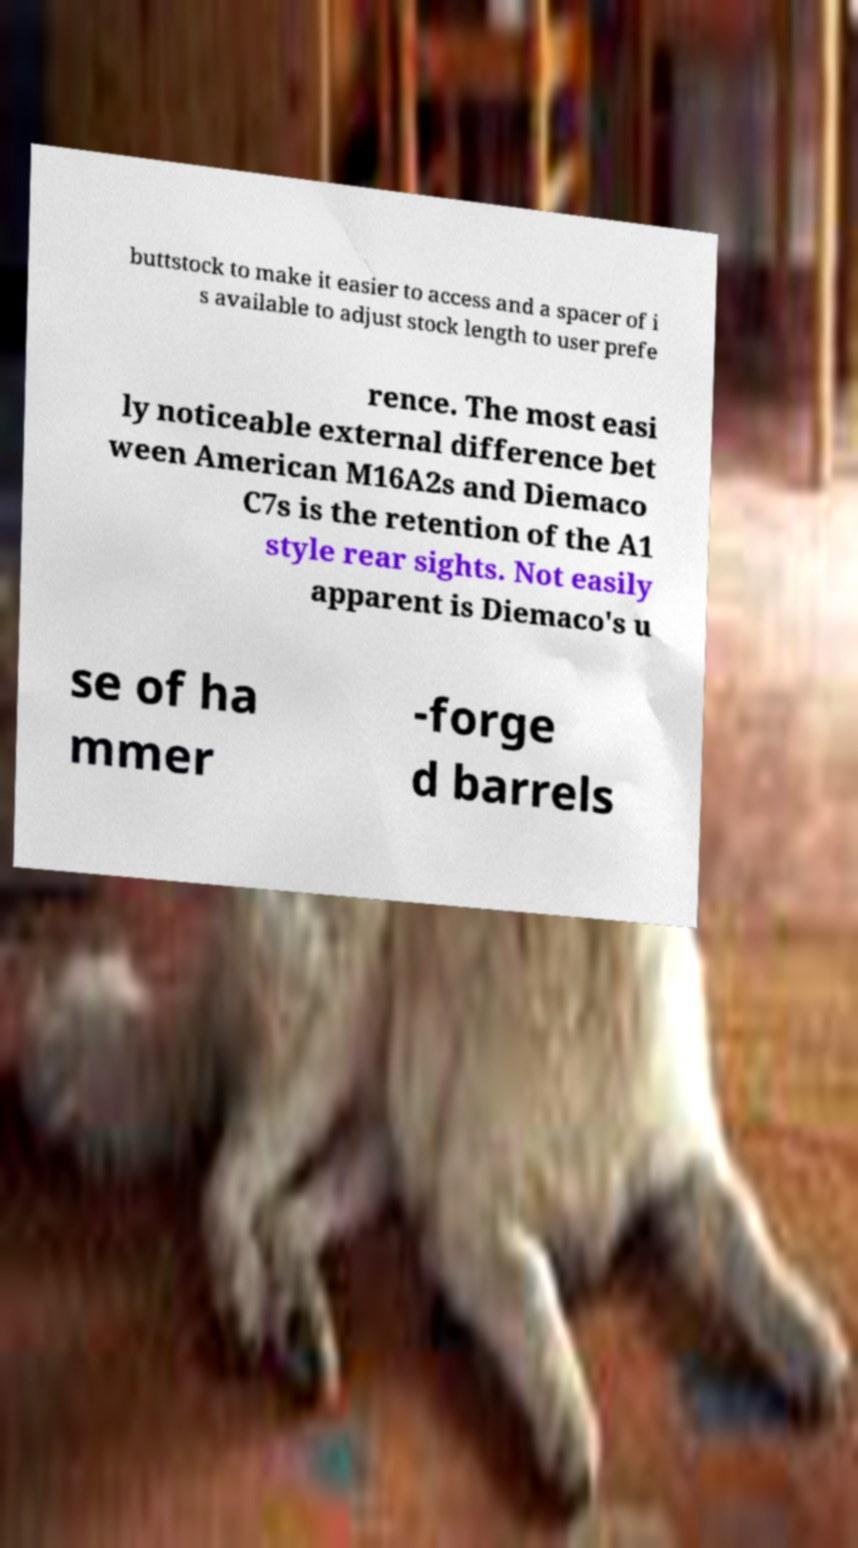Can you read and provide the text displayed in the image?This photo seems to have some interesting text. Can you extract and type it out for me? buttstock to make it easier to access and a spacer of i s available to adjust stock length to user prefe rence. The most easi ly noticeable external difference bet ween American M16A2s and Diemaco C7s is the retention of the A1 style rear sights. Not easily apparent is Diemaco's u se of ha mmer -forge d barrels 